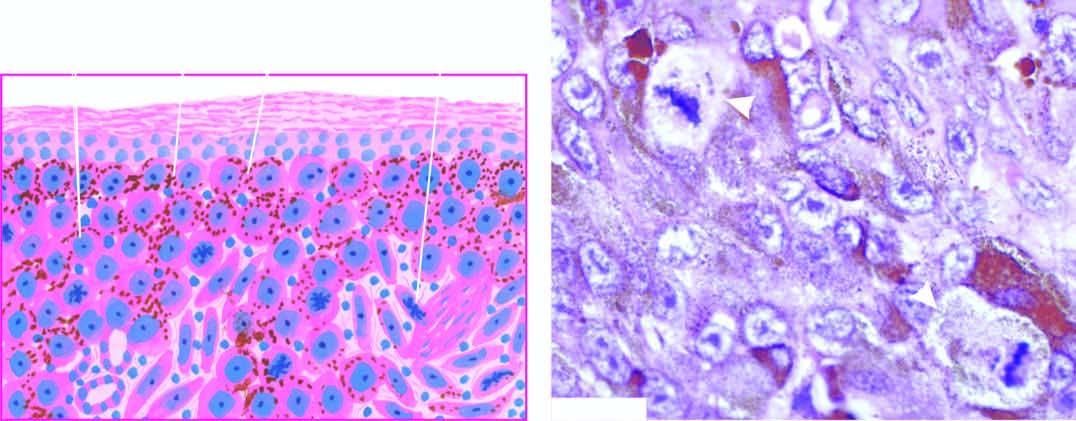do 3 components: ghon's focus, contain fine granular melanin pigment?
Answer the question using a single word or phrase. No 